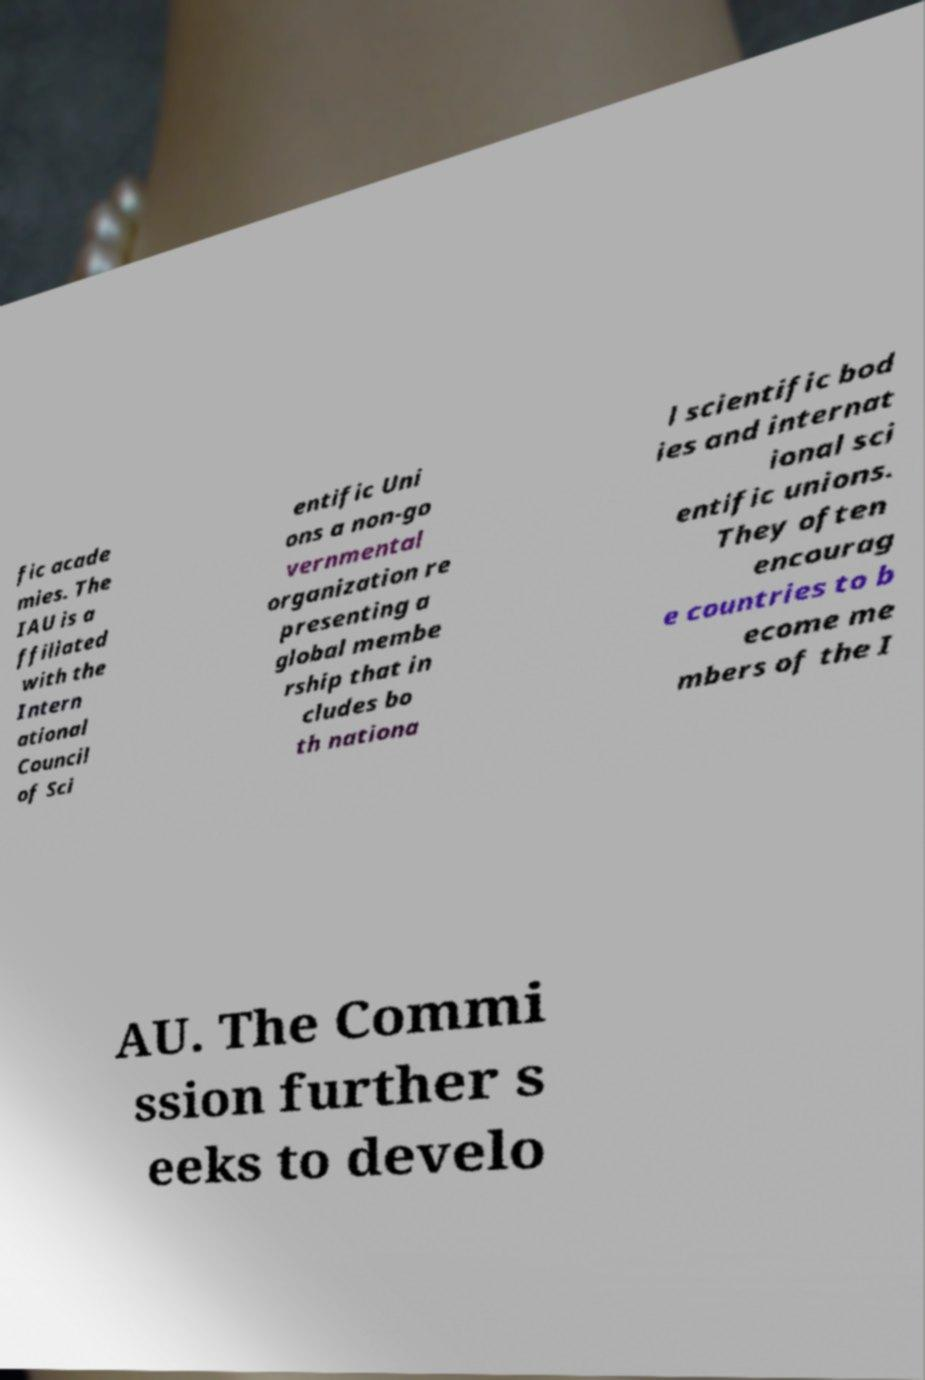What messages or text are displayed in this image? I need them in a readable, typed format. fic acade mies. The IAU is a ffiliated with the Intern ational Council of Sci entific Uni ons a non-go vernmental organization re presenting a global membe rship that in cludes bo th nationa l scientific bod ies and internat ional sci entific unions. They often encourag e countries to b ecome me mbers of the I AU. The Commi ssion further s eeks to develo 